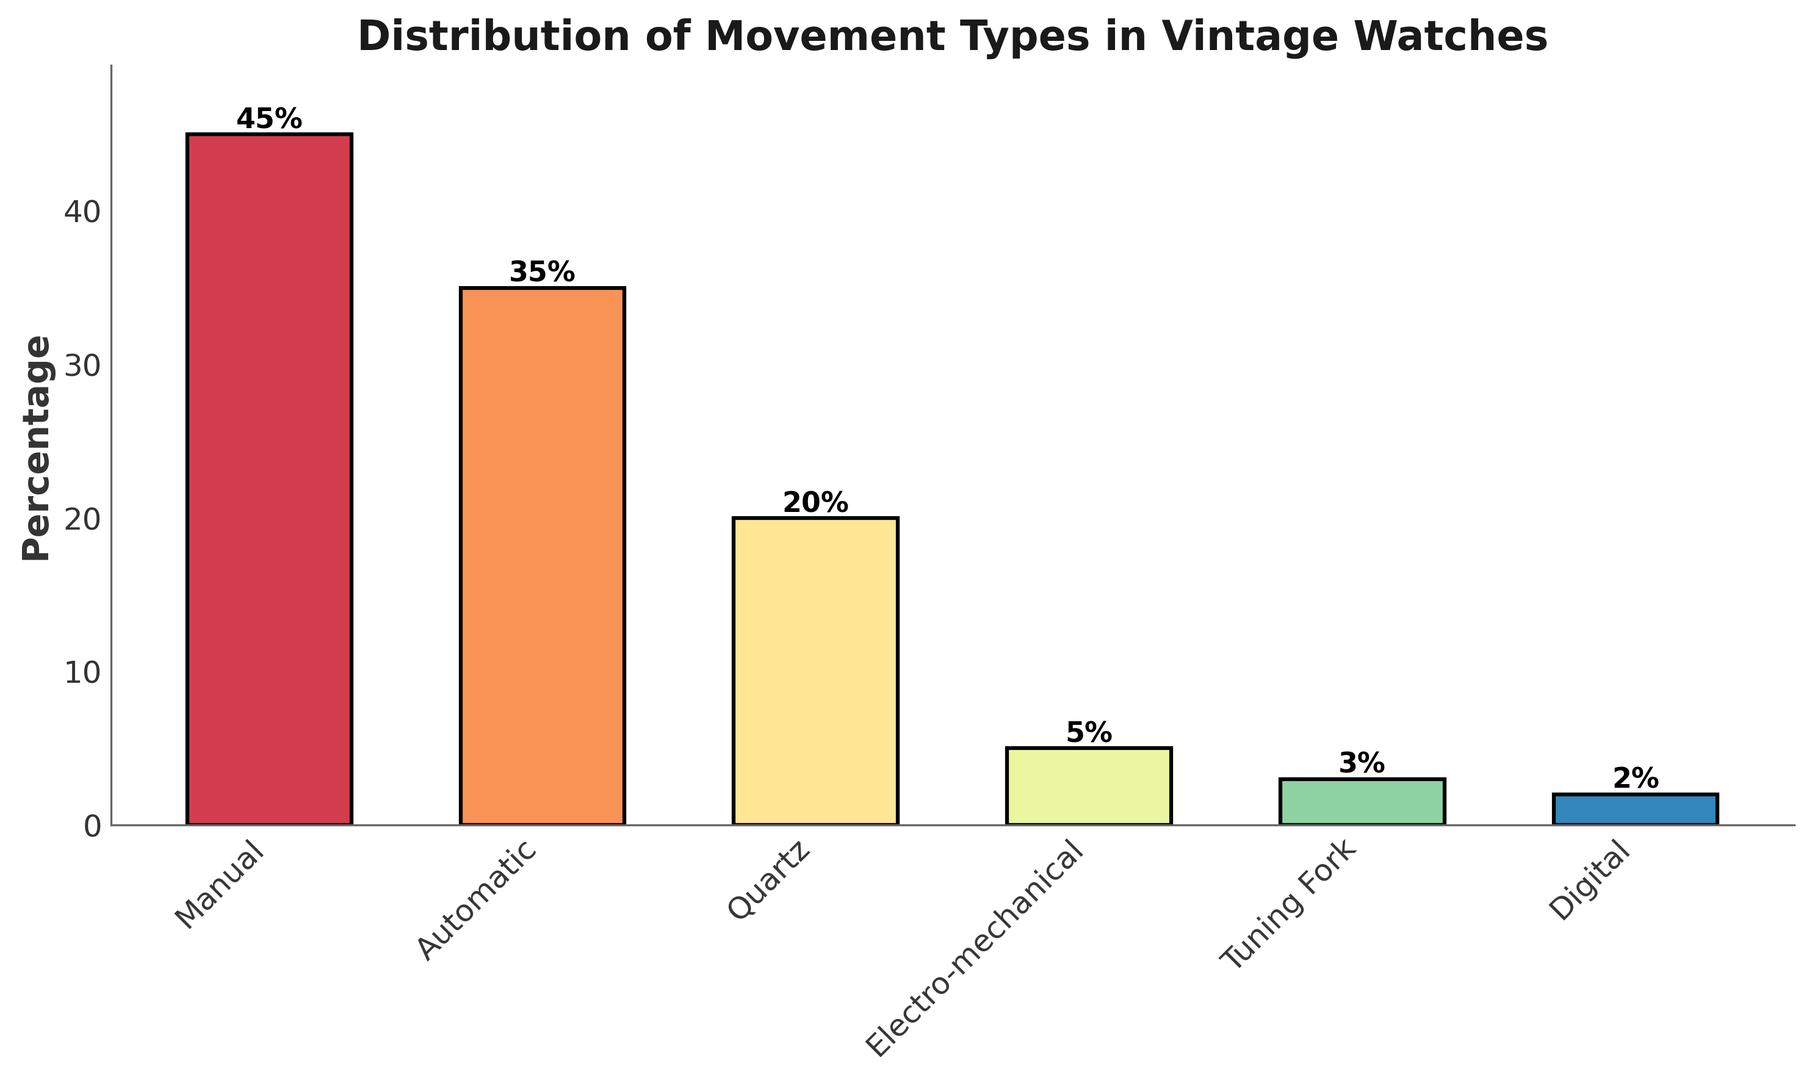Which movement type has the highest percentage? The tallest bar indicates the movement type with the highest percentage. The bar associated with 'Manual' is the tallest.
Answer: Manual How much greater is the percentage of manual movements compared to tuning fork movements? The height of the 'Manual' bar represents 45%. The height of the 'Tuning Fork' bar represents 3%. The difference is 45% - 3% = 42%.
Answer: 42% What is the combined percentage of automatic and quartz movements? The height of the 'Automatic' bar is 35% and the height of the 'Quartz' bar is 20%. The combined percentage is 35% + 20% = 55%.
Answer: 55% Which movement type has the smallest representation and what is its percentage? The shortest bar indicates the movement type with the smallest percentage. The bar associated with 'Digital' is the shortest, which is 2%.
Answer: Digital, 2% What is the total percentage of manual, automatic, and quartz movements combined in vintage watches? The heights of the 'Manual', 'Automatic', and 'Quartz' bars represent 45%, 35%, and 20%, respectively. Their total percentage is 45% + 35% + 20% = 100%.
Answer: 100% Which two movement types together have a similar percentage to automatic movements? The height of the 'Automatic' bar is 35%. The sum of 'Quartz' (20%) and 'Electro-mechanical' (5%) is 20% + 5% = 25%, which is not close. The sum of 'Tuning Fork' (3%) and 'Electro-mechanical' (5%) is 3% + 5% = 8%, which is also not close. However, the sum of 'Quartz' (20%) and 'Manual' (45%) is 20% + 45% = 65%, which is higher. 'Quartz' and 'Digital' sum to 20% + 2% = 22%, which is also lower. None of the pairs sum to 35%; instead, the closest category to 'Automatic' alone is it itself.
Answer: None What percentage of vintage watches have either tuning fork or digital movement types? The height of the 'Tuning Fork' bar is 3% and the height of the 'Digital' bar is 2%. The combined percentage is 3% + 2% = 5%.
Answer: 5% Is the percentage of electro-mechanical movements more or less than half the percentage of quartz movements? The height of the 'Electro-mechanical' bar is 5%, while the height of the 'Quartz' bar is 20%. Half of 20% is 10%. Hence, 5% is less than 10%.
Answer: Less What is the percentage difference between quartz and digital movement types? The height of the 'Quartz' bar is 20%, and the height of the 'Digital' bar is 2%. The difference is 20% - 2% = 18%.
Answer: 18% Which movement type has a percentage closest to 30%? The height of the bars indicate the percentages. The bar for 'Automatic' is 35%, which is the closest to 30% among all the listed percentages.
Answer: Automatic 